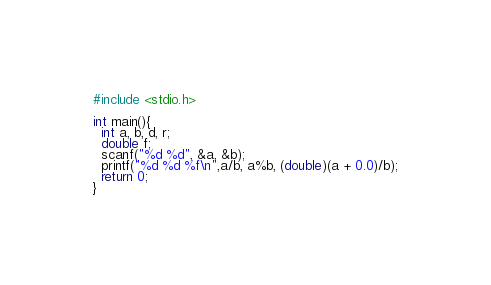<code> <loc_0><loc_0><loc_500><loc_500><_C_>#include <stdio.h>

int main(){
  int a, b, d, r;
  double f;
  scanf("%d %d", &a, &b);
  printf("%d %d %f\n",a/b, a%b, (double)(a + 0.0)/b);
  return 0;
}

</code> 